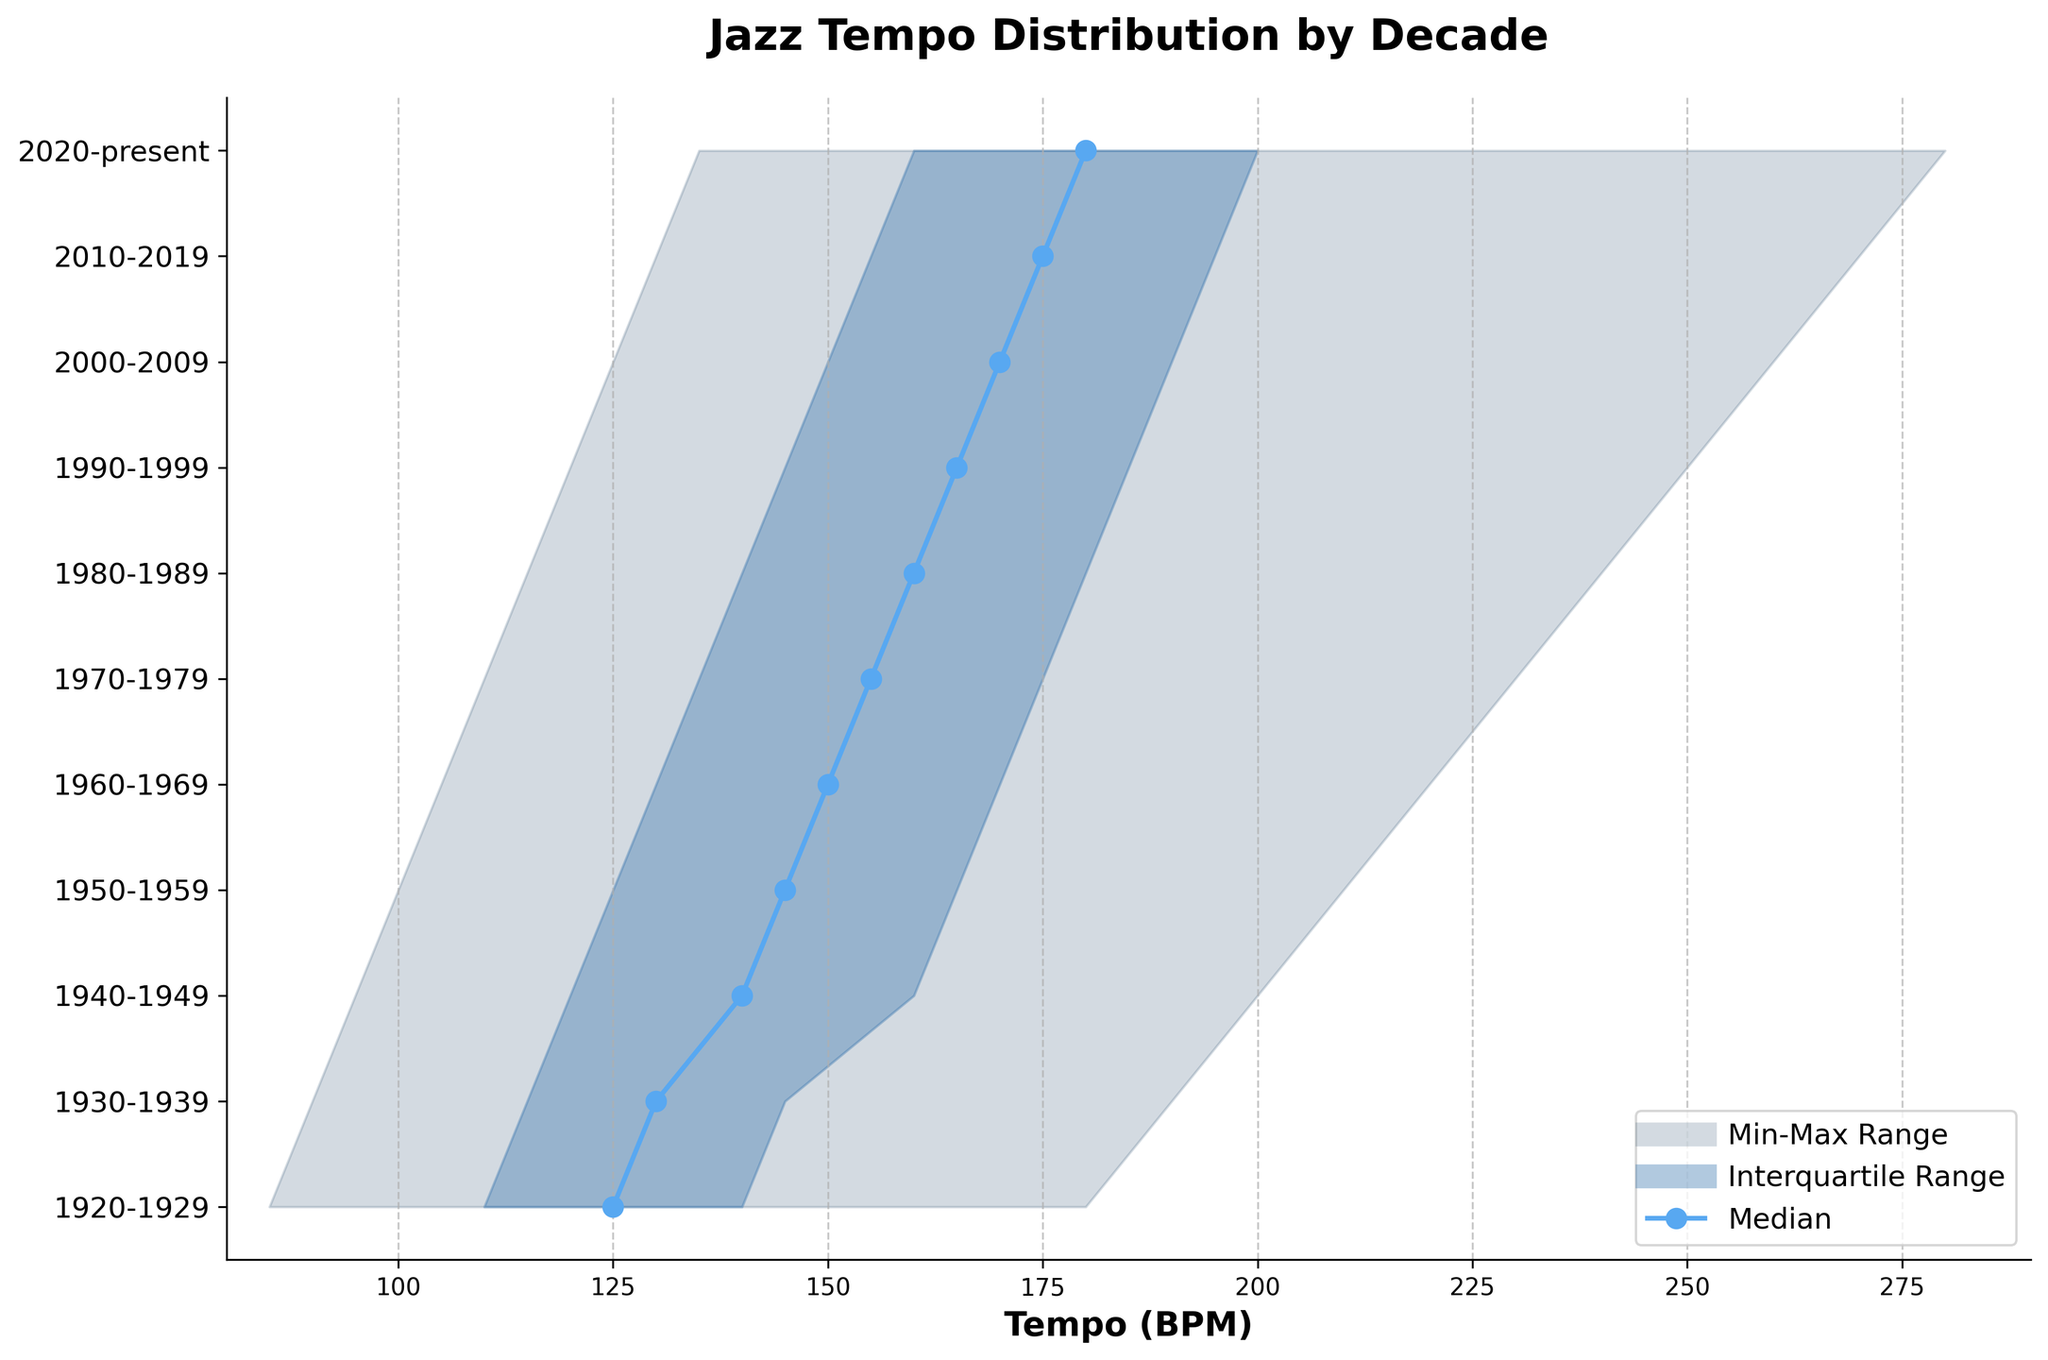What's the title of the plot? The title of the plot is written at the top of the figure. It reads "Jazz Tempo Distribution by Decade."
Answer: Jazz Tempo Distribution by Decade What does the x-axis represent? The label on the x-axis shows what it represents. According to the figure, the x-axis represents the tempo, measured in beats per minute (BPM).
Answer: Tempo (BPM) How many decades are compared in this plot? The y-axis lists the decades being compared. By counting the labels from 1920-1929 to 2020-present, we see there are 11 decades.
Answer: 11 Which decade has the highest median tempo? The median tempo for each decade is marked with a line and a circle. The decade with the median line at the highest BPM value is 2020-present.
Answer: 2020-present What is the minimum tempo for the 1920-1929 decade? By looking at the lower boundary of the shaded regions for the 1920-1929 decade on the figure, we can identify the minimum tempo, which is 85 BPM.
Answer: 85 BPM How does the interquartile range (IQR) of the 1940-1949 decade compare to the 2010-2019 decade? The IQR is the range between the first quartile (Q1) and third quartile (Q3). For 1940-1949, the IQR is from 120 BPM to 160 BPM, while for 2010-2019, it is from 155 BPM to 195 BPM. The IQR for 2010-2019 (40 BPM) is larger than the IQR for 1940-1949 (40 BPM).
Answer: Larger by 35 BPM Which decade shows the largest spread in tempo, from minimum to maximum? The spread is the difference between the minimum and maximum tempo values. The 2020-present decade has the largest spread, from 135 BPM to 280 BPM, a difference of 145 BPM.
Answer: 2020-present What is the trend in the median tempo from 1920 to present? By analyzing the plot, we can observe the trend of the median tempo values. The median tempo steadily increases from approximately 125 BPM in the 1920s to 180 BPM in the present decade.
Answer: Increasing Are there any overlapping decades where their interquartile ranges are the same? The interquartile range (IQR) for each decade is shaded. By checking the figure, no two consecutive decades share the exact same shaded region in the plot, meaning their IQRs are different.
Answer: No What range of tempos is most commonly played in Jazz music throughout the decades covered in the chart? The interquartile range (IQR) shows the middle 50% of tempos for each decade. Across all decades, these tempos generally range from about 110 BPM to 195 BPM.
Answer: 110 BPM to 195 BPM 